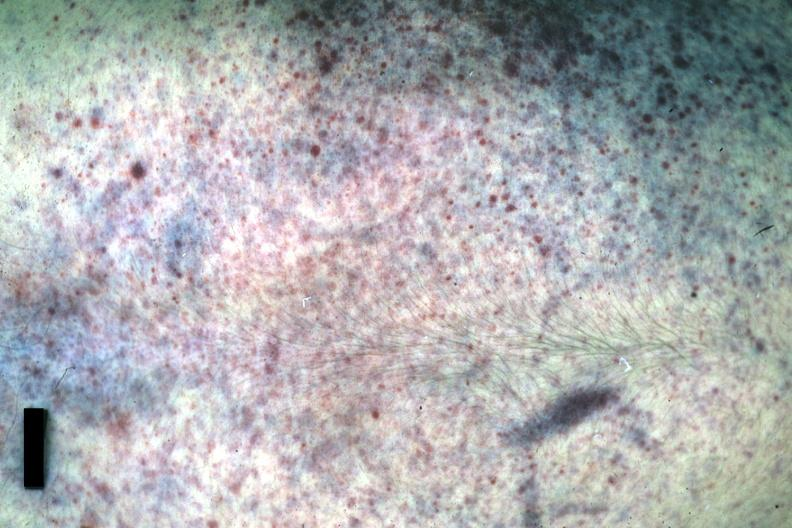what was anterior or posterior?
Answer the question using a single word or phrase. Good example either chest 